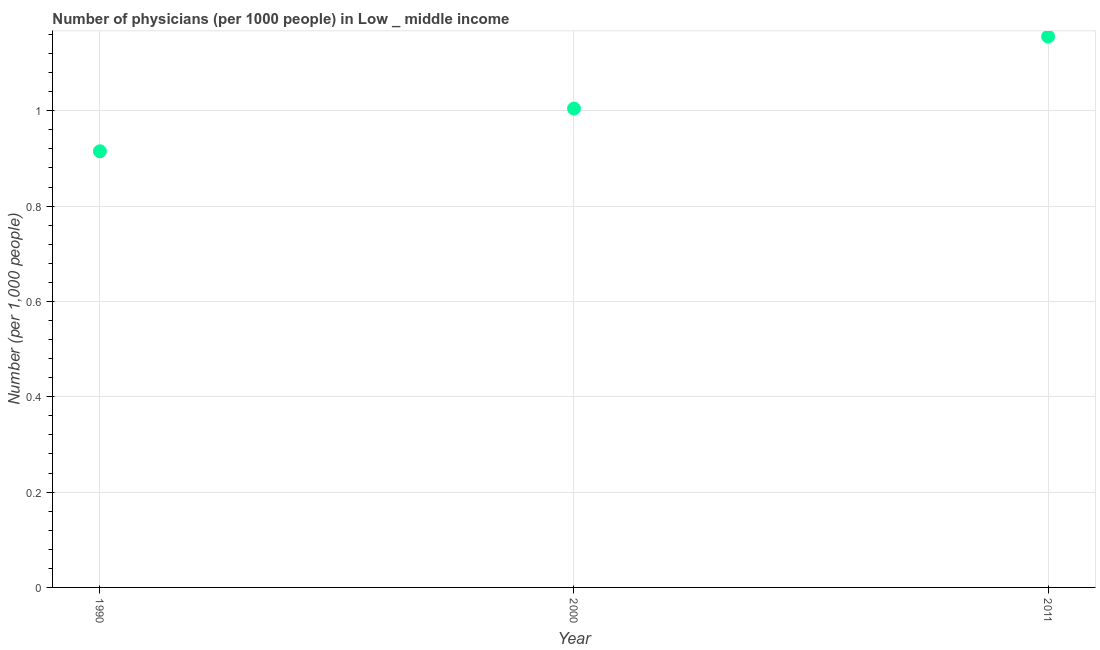What is the number of physicians in 2011?
Your response must be concise. 1.16. Across all years, what is the maximum number of physicians?
Your answer should be compact. 1.16. Across all years, what is the minimum number of physicians?
Provide a succinct answer. 0.91. In which year was the number of physicians maximum?
Offer a terse response. 2011. In which year was the number of physicians minimum?
Provide a succinct answer. 1990. What is the sum of the number of physicians?
Keep it short and to the point. 3.08. What is the difference between the number of physicians in 1990 and 2011?
Your answer should be compact. -0.24. What is the average number of physicians per year?
Your answer should be compact. 1.03. What is the median number of physicians?
Make the answer very short. 1. What is the ratio of the number of physicians in 1990 to that in 2000?
Give a very brief answer. 0.91. What is the difference between the highest and the second highest number of physicians?
Ensure brevity in your answer.  0.15. What is the difference between the highest and the lowest number of physicians?
Keep it short and to the point. 0.24. Does the number of physicians monotonically increase over the years?
Provide a short and direct response. Yes. How many dotlines are there?
Offer a very short reply. 1. How many years are there in the graph?
Your answer should be very brief. 3. What is the difference between two consecutive major ticks on the Y-axis?
Offer a terse response. 0.2. Does the graph contain grids?
Provide a short and direct response. Yes. What is the title of the graph?
Offer a very short reply. Number of physicians (per 1000 people) in Low _ middle income. What is the label or title of the X-axis?
Your response must be concise. Year. What is the label or title of the Y-axis?
Offer a terse response. Number (per 1,0 people). What is the Number (per 1,000 people) in 1990?
Your answer should be very brief. 0.91. What is the Number (per 1,000 people) in 2000?
Give a very brief answer. 1. What is the Number (per 1,000 people) in 2011?
Ensure brevity in your answer.  1.16. What is the difference between the Number (per 1,000 people) in 1990 and 2000?
Your answer should be very brief. -0.09. What is the difference between the Number (per 1,000 people) in 1990 and 2011?
Ensure brevity in your answer.  -0.24. What is the difference between the Number (per 1,000 people) in 2000 and 2011?
Provide a succinct answer. -0.15. What is the ratio of the Number (per 1,000 people) in 1990 to that in 2000?
Offer a very short reply. 0.91. What is the ratio of the Number (per 1,000 people) in 1990 to that in 2011?
Your answer should be compact. 0.79. What is the ratio of the Number (per 1,000 people) in 2000 to that in 2011?
Ensure brevity in your answer.  0.87. 